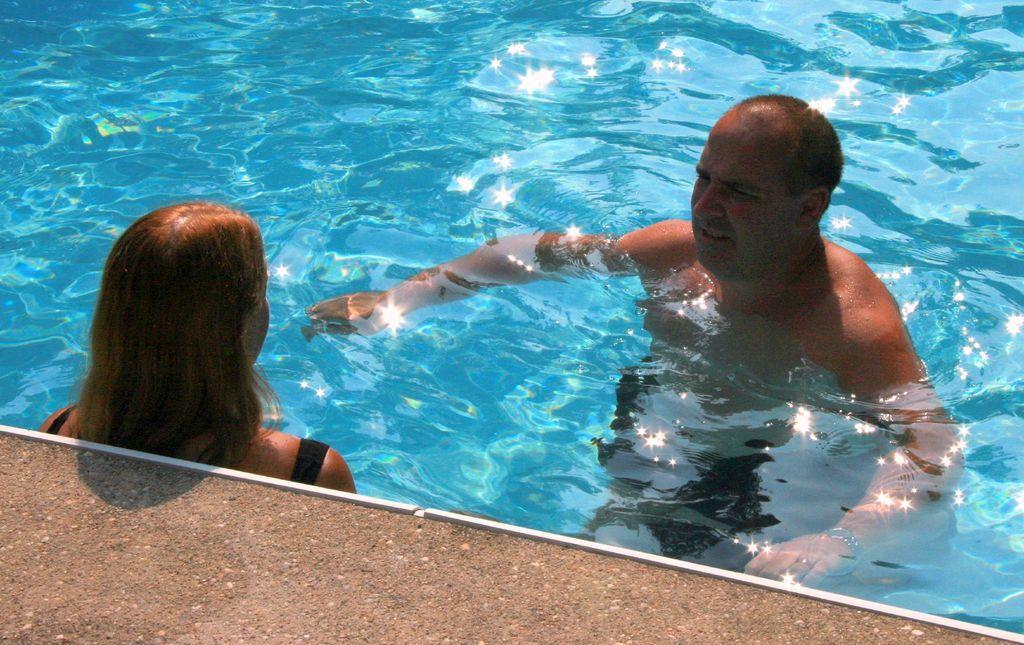How would you summarize this image in a sentence or two? In the picture we can see a swimming pool which is blue in color with water and in it we can see a man and a woman and beside the pool we can see a path. 